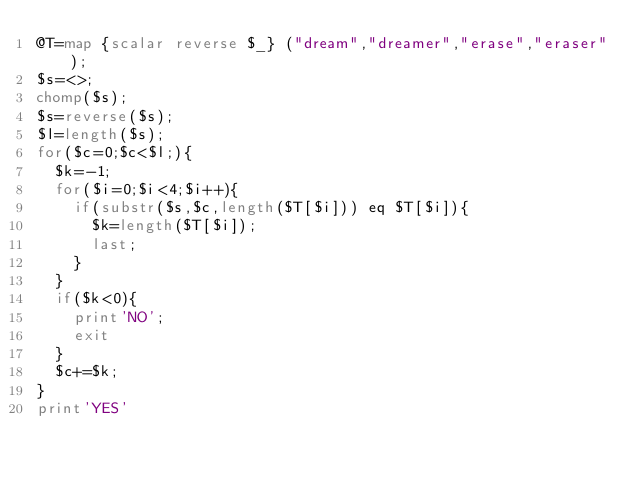Convert code to text. <code><loc_0><loc_0><loc_500><loc_500><_Perl_>@T=map {scalar reverse $_} ("dream","dreamer","erase","eraser");
$s=<>;
chomp($s);
$s=reverse($s);
$l=length($s);
for($c=0;$c<$l;){
	$k=-1;
	for($i=0;$i<4;$i++){
		if(substr($s,$c,length($T[$i])) eq $T[$i]){
			$k=length($T[$i]);
			last;
		}
	}
	if($k<0){
		print'NO';
		exit
	}
	$c+=$k;
}
print'YES'</code> 